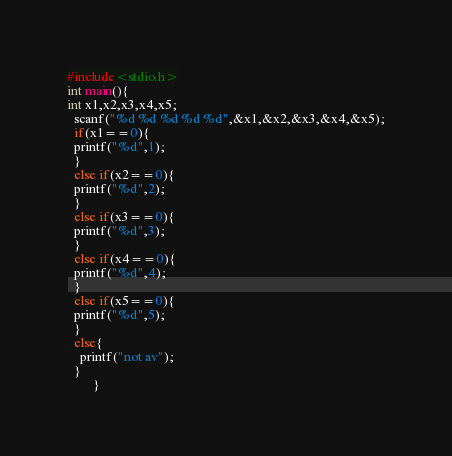Convert code to text. <code><loc_0><loc_0><loc_500><loc_500><_C_>#include<stdio.h>
int main(){
int x1,x2,x3,x4,x5;
  scanf("%d %d %d %d %d",&x1,&x2,&x3,&x4,&x5);
  if(x1==0){
  printf("%d",1);
  }
  else if(x2==0){
  printf("%d",2);
  }
  else if(x3==0){
  printf("%d",3);
  }
  else if(x4==0){
  printf("%d",4);
  }
  else if(x5==0){
  printf("%d",5);
  }
  else{
  	printf("not av");
  }
        }</code> 